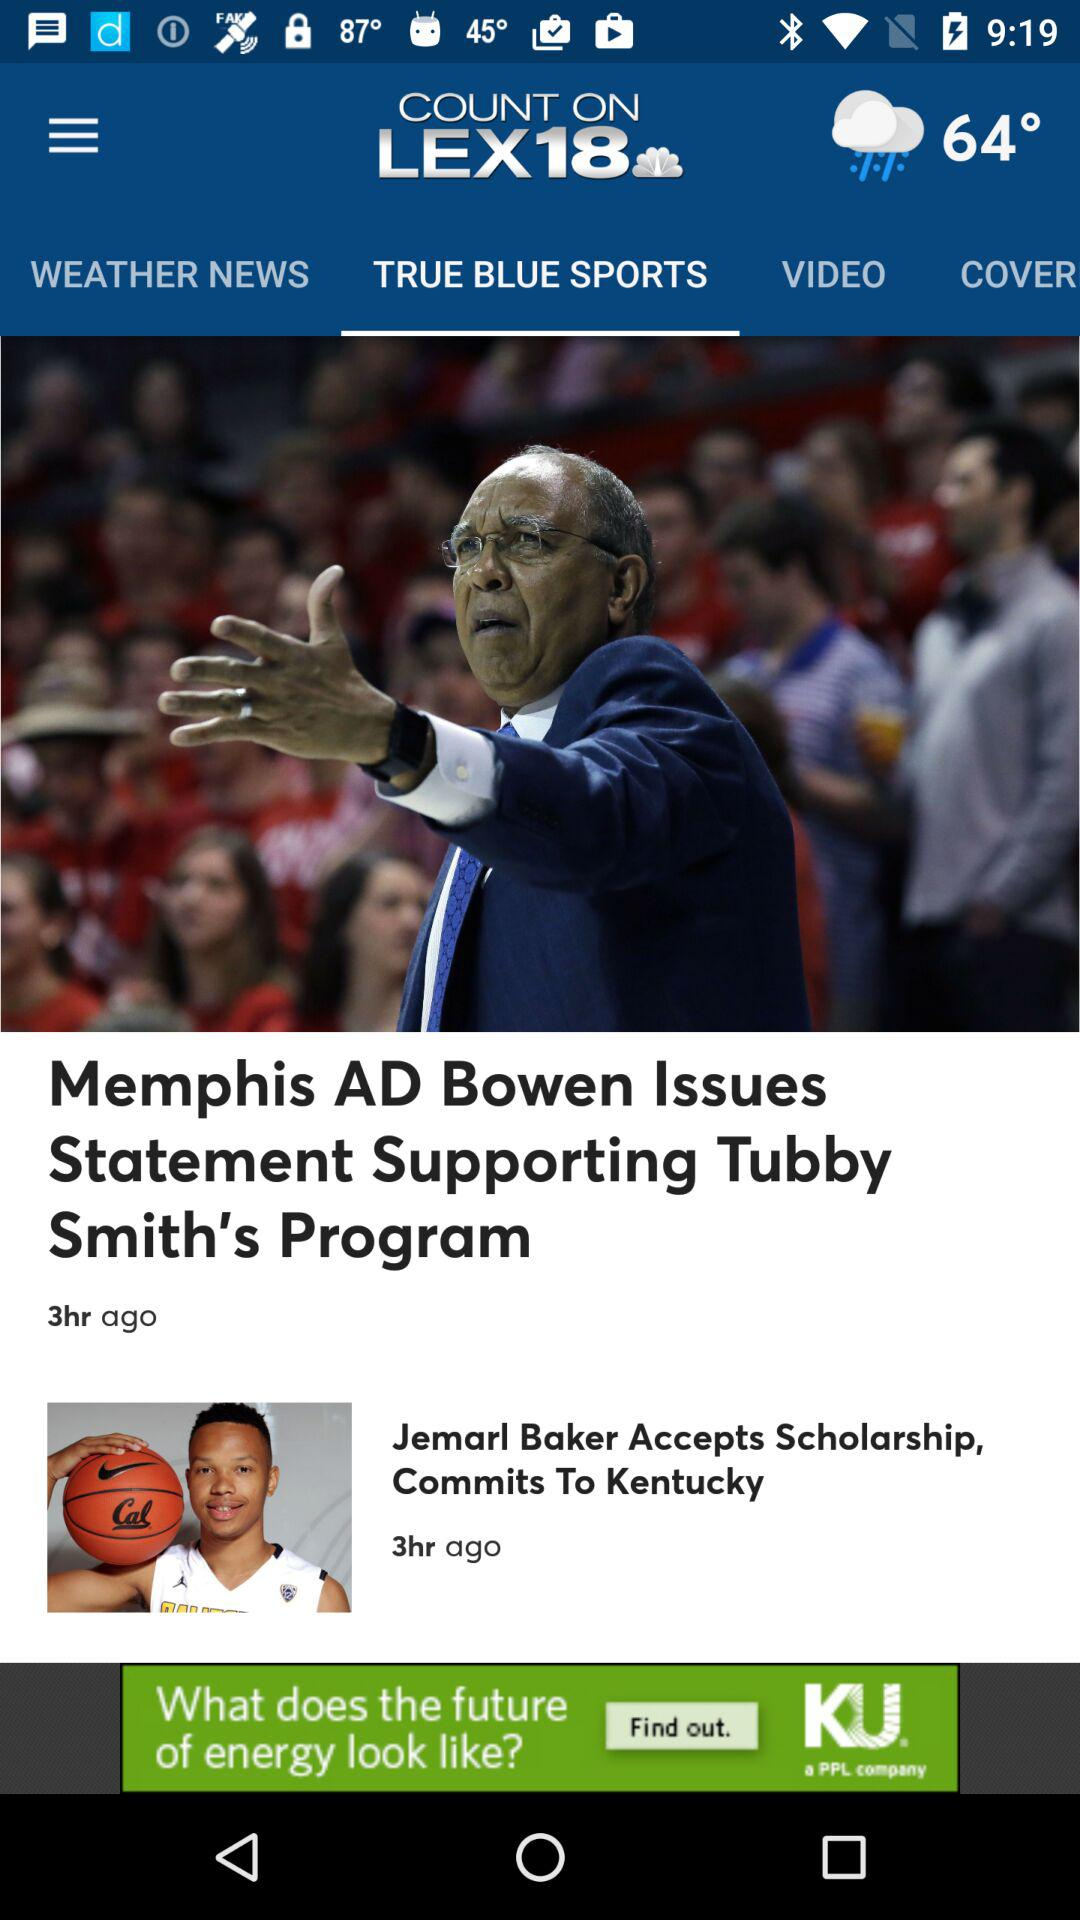When was the article "Jemarl Baker Accepts Scholarship, Commits To Kentucky" posted? The article "Jemarl Baker Accepts Scholarship, Commits To Kentucky" was posted 3 hours ago. 